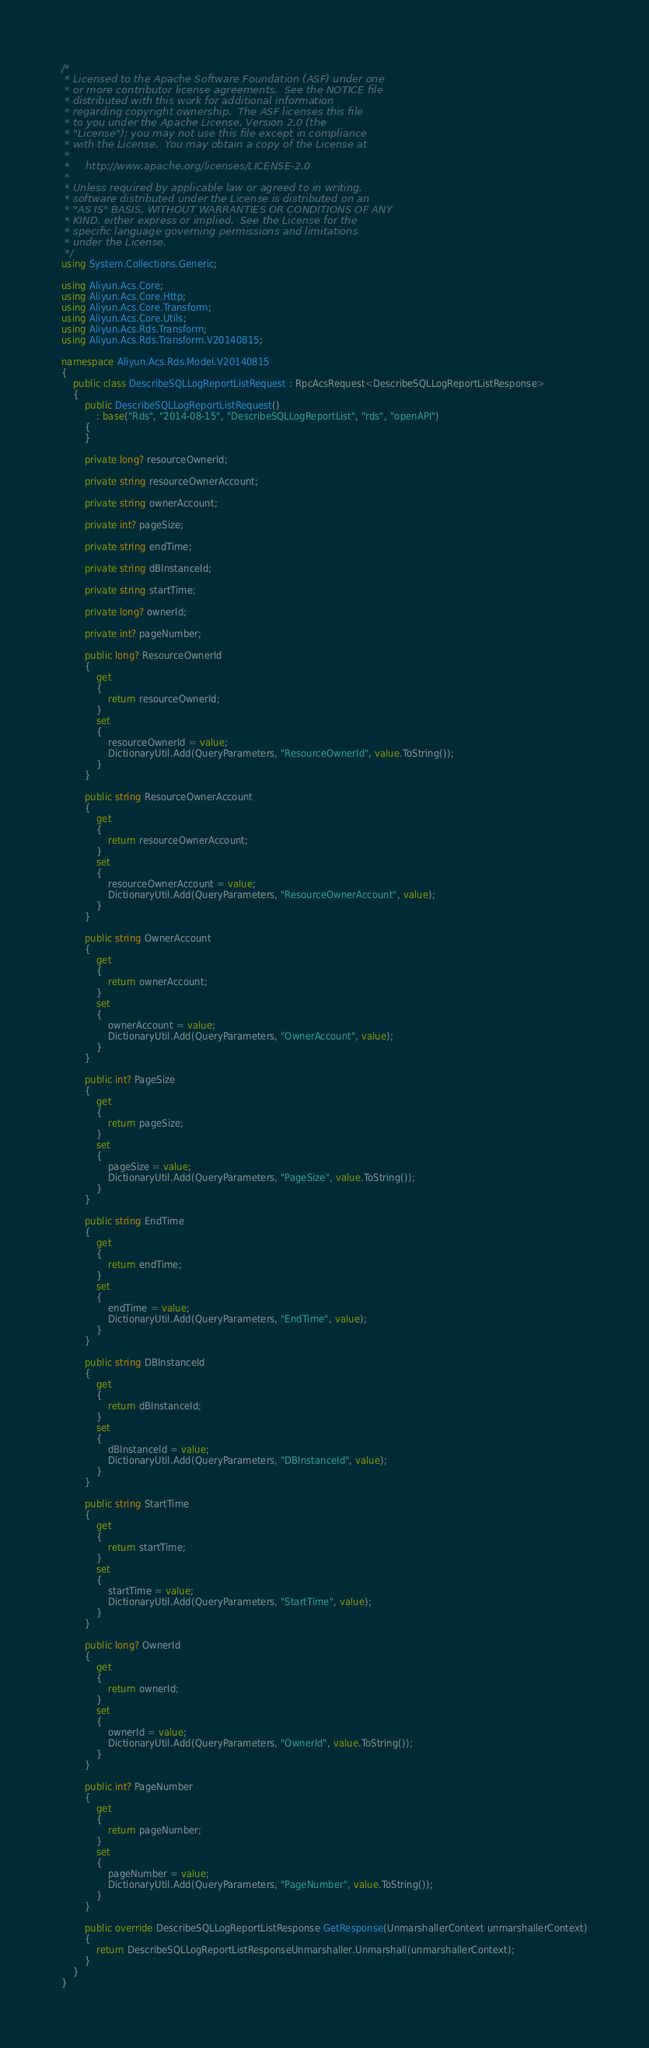Convert code to text. <code><loc_0><loc_0><loc_500><loc_500><_C#_>/*
 * Licensed to the Apache Software Foundation (ASF) under one
 * or more contributor license agreements.  See the NOTICE file
 * distributed with this work for additional information
 * regarding copyright ownership.  The ASF licenses this file
 * to you under the Apache License, Version 2.0 (the
 * "License"); you may not use this file except in compliance
 * with the License.  You may obtain a copy of the License at
 *
 *     http://www.apache.org/licenses/LICENSE-2.0
 *
 * Unless required by applicable law or agreed to in writing,
 * software distributed under the License is distributed on an
 * "AS IS" BASIS, WITHOUT WARRANTIES OR CONDITIONS OF ANY
 * KIND, either express or implied.  See the License for the
 * specific language governing permissions and limitations
 * under the License.
 */
using System.Collections.Generic;

using Aliyun.Acs.Core;
using Aliyun.Acs.Core.Http;
using Aliyun.Acs.Core.Transform;
using Aliyun.Acs.Core.Utils;
using Aliyun.Acs.Rds.Transform;
using Aliyun.Acs.Rds.Transform.V20140815;

namespace Aliyun.Acs.Rds.Model.V20140815
{
    public class DescribeSQLLogReportListRequest : RpcAcsRequest<DescribeSQLLogReportListResponse>
    {
        public DescribeSQLLogReportListRequest()
            : base("Rds", "2014-08-15", "DescribeSQLLogReportList", "rds", "openAPI")
        {
        }

		private long? resourceOwnerId;

		private string resourceOwnerAccount;

		private string ownerAccount;

		private int? pageSize;

		private string endTime;

		private string dBInstanceId;

		private string startTime;

		private long? ownerId;

		private int? pageNumber;

		public long? ResourceOwnerId
		{
			get
			{
				return resourceOwnerId;
			}
			set	
			{
				resourceOwnerId = value;
				DictionaryUtil.Add(QueryParameters, "ResourceOwnerId", value.ToString());
			}
		}

		public string ResourceOwnerAccount
		{
			get
			{
				return resourceOwnerAccount;
			}
			set	
			{
				resourceOwnerAccount = value;
				DictionaryUtil.Add(QueryParameters, "ResourceOwnerAccount", value);
			}
		}

		public string OwnerAccount
		{
			get
			{
				return ownerAccount;
			}
			set	
			{
				ownerAccount = value;
				DictionaryUtil.Add(QueryParameters, "OwnerAccount", value);
			}
		}

		public int? PageSize
		{
			get
			{
				return pageSize;
			}
			set	
			{
				pageSize = value;
				DictionaryUtil.Add(QueryParameters, "PageSize", value.ToString());
			}
		}

		public string EndTime
		{
			get
			{
				return endTime;
			}
			set	
			{
				endTime = value;
				DictionaryUtil.Add(QueryParameters, "EndTime", value);
			}
		}

		public string DBInstanceId
		{
			get
			{
				return dBInstanceId;
			}
			set	
			{
				dBInstanceId = value;
				DictionaryUtil.Add(QueryParameters, "DBInstanceId", value);
			}
		}

		public string StartTime
		{
			get
			{
				return startTime;
			}
			set	
			{
				startTime = value;
				DictionaryUtil.Add(QueryParameters, "StartTime", value);
			}
		}

		public long? OwnerId
		{
			get
			{
				return ownerId;
			}
			set	
			{
				ownerId = value;
				DictionaryUtil.Add(QueryParameters, "OwnerId", value.ToString());
			}
		}

		public int? PageNumber
		{
			get
			{
				return pageNumber;
			}
			set	
			{
				pageNumber = value;
				DictionaryUtil.Add(QueryParameters, "PageNumber", value.ToString());
			}
		}

        public override DescribeSQLLogReportListResponse GetResponse(UnmarshallerContext unmarshallerContext)
        {
            return DescribeSQLLogReportListResponseUnmarshaller.Unmarshall(unmarshallerContext);
        }
    }
}
</code> 